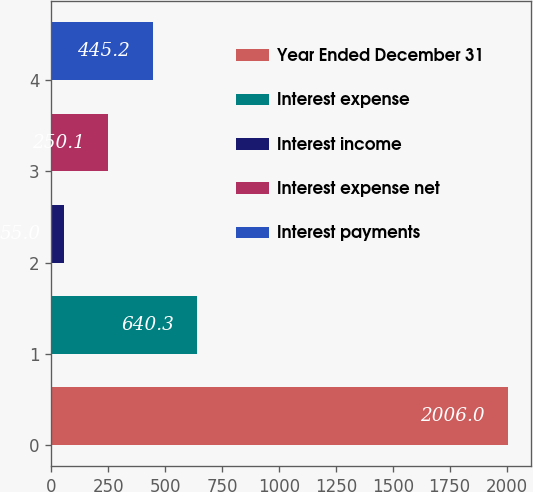Convert chart. <chart><loc_0><loc_0><loc_500><loc_500><bar_chart><fcel>Year Ended December 31<fcel>Interest expense<fcel>Interest income<fcel>Interest expense net<fcel>Interest payments<nl><fcel>2006<fcel>640.3<fcel>55<fcel>250.1<fcel>445.2<nl></chart> 